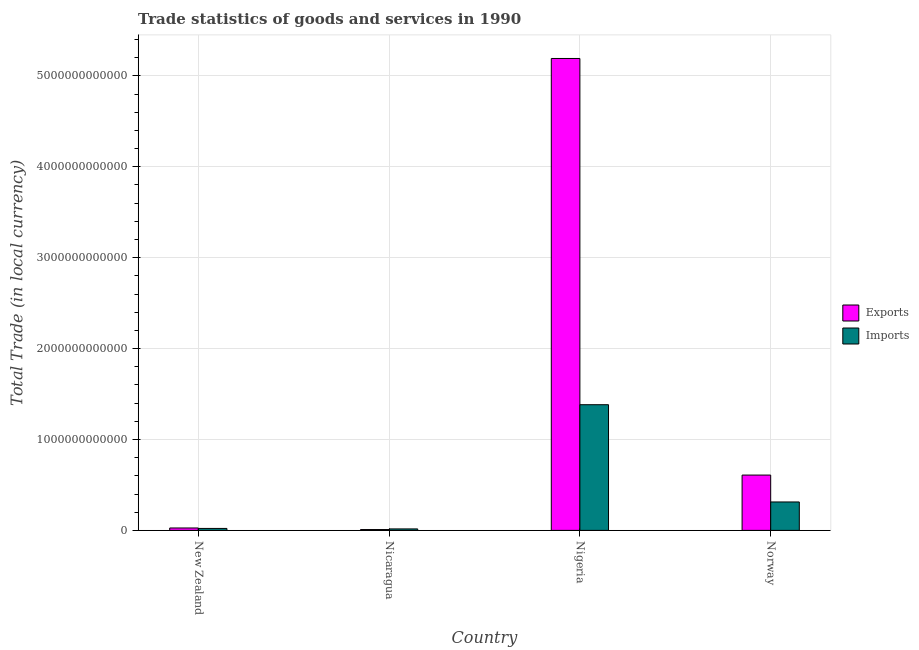How many groups of bars are there?
Your answer should be compact. 4. Are the number of bars on each tick of the X-axis equal?
Your answer should be very brief. Yes. How many bars are there on the 4th tick from the right?
Your answer should be compact. 2. What is the label of the 2nd group of bars from the left?
Your response must be concise. Nicaragua. In how many cases, is the number of bars for a given country not equal to the number of legend labels?
Your answer should be compact. 0. What is the imports of goods and services in Nicaragua?
Ensure brevity in your answer.  1.62e+1. Across all countries, what is the maximum export of goods and services?
Your answer should be very brief. 5.19e+12. Across all countries, what is the minimum imports of goods and services?
Keep it short and to the point. 1.62e+1. In which country was the imports of goods and services maximum?
Ensure brevity in your answer.  Nigeria. In which country was the export of goods and services minimum?
Give a very brief answer. Nicaragua. What is the total export of goods and services in the graph?
Offer a very short reply. 5.84e+12. What is the difference between the export of goods and services in New Zealand and that in Nicaragua?
Keep it short and to the point. 1.73e+1. What is the difference between the export of goods and services in New Zealand and the imports of goods and services in Norway?
Your answer should be compact. -2.86e+11. What is the average imports of goods and services per country?
Your answer should be very brief. 4.33e+11. What is the difference between the export of goods and services and imports of goods and services in Norway?
Provide a succinct answer. 2.96e+11. In how many countries, is the imports of goods and services greater than 5200000000000 LCU?
Keep it short and to the point. 0. What is the ratio of the export of goods and services in New Zealand to that in Nigeria?
Provide a short and direct response. 0.01. Is the difference between the export of goods and services in New Zealand and Nigeria greater than the difference between the imports of goods and services in New Zealand and Nigeria?
Your response must be concise. No. What is the difference between the highest and the second highest imports of goods and services?
Your response must be concise. 1.07e+12. What is the difference between the highest and the lowest export of goods and services?
Provide a succinct answer. 5.18e+12. Is the sum of the export of goods and services in Nicaragua and Nigeria greater than the maximum imports of goods and services across all countries?
Provide a succinct answer. Yes. What does the 2nd bar from the left in Nigeria represents?
Your response must be concise. Imports. What does the 1st bar from the right in New Zealand represents?
Make the answer very short. Imports. How many bars are there?
Provide a succinct answer. 8. How many countries are there in the graph?
Offer a terse response. 4. What is the difference between two consecutive major ticks on the Y-axis?
Ensure brevity in your answer.  1.00e+12. Are the values on the major ticks of Y-axis written in scientific E-notation?
Your answer should be very brief. No. Does the graph contain any zero values?
Offer a very short reply. No. Where does the legend appear in the graph?
Your answer should be very brief. Center right. How are the legend labels stacked?
Keep it short and to the point. Vertical. What is the title of the graph?
Your response must be concise. Trade statistics of goods and services in 1990. Does "Primary education" appear as one of the legend labels in the graph?
Make the answer very short. No. What is the label or title of the Y-axis?
Provide a succinct answer. Total Trade (in local currency). What is the Total Trade (in local currency) of Exports in New Zealand?
Make the answer very short. 2.66e+1. What is the Total Trade (in local currency) in Imports in New Zealand?
Offer a terse response. 2.16e+1. What is the Total Trade (in local currency) of Exports in Nicaragua?
Offer a very short reply. 9.34e+09. What is the Total Trade (in local currency) in Imports in Nicaragua?
Give a very brief answer. 1.62e+1. What is the Total Trade (in local currency) of Exports in Nigeria?
Provide a succinct answer. 5.19e+12. What is the Total Trade (in local currency) in Imports in Nigeria?
Make the answer very short. 1.38e+12. What is the Total Trade (in local currency) in Exports in Norway?
Offer a very short reply. 6.09e+11. What is the Total Trade (in local currency) of Imports in Norway?
Provide a succinct answer. 3.13e+11. Across all countries, what is the maximum Total Trade (in local currency) of Exports?
Your answer should be compact. 5.19e+12. Across all countries, what is the maximum Total Trade (in local currency) in Imports?
Your response must be concise. 1.38e+12. Across all countries, what is the minimum Total Trade (in local currency) of Exports?
Keep it short and to the point. 9.34e+09. Across all countries, what is the minimum Total Trade (in local currency) of Imports?
Your answer should be very brief. 1.62e+1. What is the total Total Trade (in local currency) in Exports in the graph?
Provide a succinct answer. 5.84e+12. What is the total Total Trade (in local currency) in Imports in the graph?
Provide a succinct answer. 1.73e+12. What is the difference between the Total Trade (in local currency) of Exports in New Zealand and that in Nicaragua?
Ensure brevity in your answer.  1.73e+1. What is the difference between the Total Trade (in local currency) in Imports in New Zealand and that in Nicaragua?
Offer a very short reply. 5.36e+09. What is the difference between the Total Trade (in local currency) in Exports in New Zealand and that in Nigeria?
Your response must be concise. -5.17e+12. What is the difference between the Total Trade (in local currency) of Imports in New Zealand and that in Nigeria?
Keep it short and to the point. -1.36e+12. What is the difference between the Total Trade (in local currency) of Exports in New Zealand and that in Norway?
Provide a succinct answer. -5.82e+11. What is the difference between the Total Trade (in local currency) in Imports in New Zealand and that in Norway?
Ensure brevity in your answer.  -2.91e+11. What is the difference between the Total Trade (in local currency) in Exports in Nicaragua and that in Nigeria?
Give a very brief answer. -5.18e+12. What is the difference between the Total Trade (in local currency) of Imports in Nicaragua and that in Nigeria?
Offer a very short reply. -1.37e+12. What is the difference between the Total Trade (in local currency) in Exports in Nicaragua and that in Norway?
Offer a terse response. -5.99e+11. What is the difference between the Total Trade (in local currency) of Imports in Nicaragua and that in Norway?
Give a very brief answer. -2.97e+11. What is the difference between the Total Trade (in local currency) in Exports in Nigeria and that in Norway?
Offer a very short reply. 4.58e+12. What is the difference between the Total Trade (in local currency) of Imports in Nigeria and that in Norway?
Your answer should be compact. 1.07e+12. What is the difference between the Total Trade (in local currency) of Exports in New Zealand and the Total Trade (in local currency) of Imports in Nicaragua?
Your answer should be compact. 1.04e+1. What is the difference between the Total Trade (in local currency) of Exports in New Zealand and the Total Trade (in local currency) of Imports in Nigeria?
Your response must be concise. -1.36e+12. What is the difference between the Total Trade (in local currency) in Exports in New Zealand and the Total Trade (in local currency) in Imports in Norway?
Keep it short and to the point. -2.86e+11. What is the difference between the Total Trade (in local currency) in Exports in Nicaragua and the Total Trade (in local currency) in Imports in Nigeria?
Offer a terse response. -1.37e+12. What is the difference between the Total Trade (in local currency) of Exports in Nicaragua and the Total Trade (in local currency) of Imports in Norway?
Your answer should be very brief. -3.03e+11. What is the difference between the Total Trade (in local currency) of Exports in Nigeria and the Total Trade (in local currency) of Imports in Norway?
Your answer should be compact. 4.88e+12. What is the average Total Trade (in local currency) in Exports per country?
Offer a very short reply. 1.46e+12. What is the average Total Trade (in local currency) in Imports per country?
Ensure brevity in your answer.  4.33e+11. What is the difference between the Total Trade (in local currency) of Exports and Total Trade (in local currency) of Imports in New Zealand?
Give a very brief answer. 5.04e+09. What is the difference between the Total Trade (in local currency) of Exports and Total Trade (in local currency) of Imports in Nicaragua?
Offer a very short reply. -6.88e+09. What is the difference between the Total Trade (in local currency) of Exports and Total Trade (in local currency) of Imports in Nigeria?
Offer a terse response. 3.81e+12. What is the difference between the Total Trade (in local currency) of Exports and Total Trade (in local currency) of Imports in Norway?
Your answer should be compact. 2.96e+11. What is the ratio of the Total Trade (in local currency) in Exports in New Zealand to that in Nicaragua?
Keep it short and to the point. 2.85. What is the ratio of the Total Trade (in local currency) in Imports in New Zealand to that in Nicaragua?
Provide a short and direct response. 1.33. What is the ratio of the Total Trade (in local currency) of Exports in New Zealand to that in Nigeria?
Your response must be concise. 0.01. What is the ratio of the Total Trade (in local currency) of Imports in New Zealand to that in Nigeria?
Provide a succinct answer. 0.02. What is the ratio of the Total Trade (in local currency) of Exports in New Zealand to that in Norway?
Give a very brief answer. 0.04. What is the ratio of the Total Trade (in local currency) in Imports in New Zealand to that in Norway?
Your response must be concise. 0.07. What is the ratio of the Total Trade (in local currency) of Exports in Nicaragua to that in Nigeria?
Your answer should be very brief. 0. What is the ratio of the Total Trade (in local currency) of Imports in Nicaragua to that in Nigeria?
Offer a very short reply. 0.01. What is the ratio of the Total Trade (in local currency) of Exports in Nicaragua to that in Norway?
Ensure brevity in your answer.  0.02. What is the ratio of the Total Trade (in local currency) of Imports in Nicaragua to that in Norway?
Offer a very short reply. 0.05. What is the ratio of the Total Trade (in local currency) in Exports in Nigeria to that in Norway?
Ensure brevity in your answer.  8.53. What is the ratio of the Total Trade (in local currency) in Imports in Nigeria to that in Norway?
Give a very brief answer. 4.42. What is the difference between the highest and the second highest Total Trade (in local currency) of Exports?
Keep it short and to the point. 4.58e+12. What is the difference between the highest and the second highest Total Trade (in local currency) in Imports?
Make the answer very short. 1.07e+12. What is the difference between the highest and the lowest Total Trade (in local currency) in Exports?
Offer a very short reply. 5.18e+12. What is the difference between the highest and the lowest Total Trade (in local currency) of Imports?
Ensure brevity in your answer.  1.37e+12. 